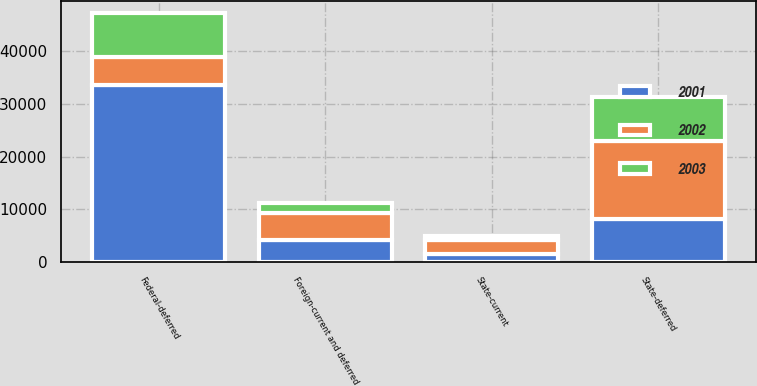<chart> <loc_0><loc_0><loc_500><loc_500><stacked_bar_chart><ecel><fcel>Federal-deferred<fcel>State-current<fcel>State-deferred<fcel>Foreign-current and deferred<nl><fcel>2003<fcel>8332<fcel>726<fcel>8359<fcel>1910<nl><fcel>2001<fcel>33629<fcel>1447<fcel>8121<fcel>4121<nl><fcel>2002<fcel>5245<fcel>2758<fcel>14871<fcel>5245<nl></chart> 